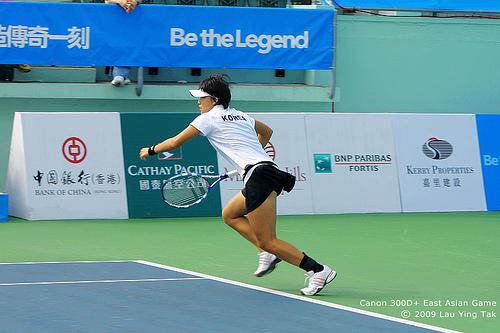What color is the uniform that the tennis player is wearing?
Be succinct. Black and white. What hand is the player holding the racket with?
Be succinct. Right. Who are the sponsors of this match?
Quick response, please. Cathay pacific. 